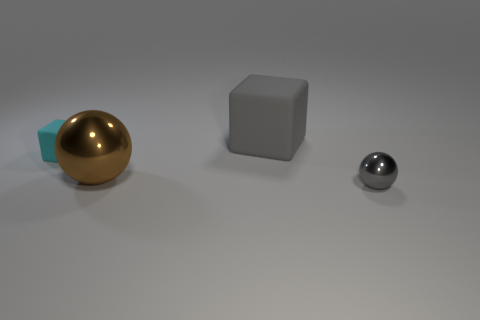Is there a object of the same color as the tiny rubber block?
Your answer should be very brief. No. There is a tiny gray thing that is made of the same material as the big brown ball; what shape is it?
Ensure brevity in your answer.  Sphere. Is the color of the tiny metal ball the same as the big cube?
Give a very brief answer. Yes. What is the material of the gray object that is the same shape as the big brown thing?
Provide a succinct answer. Metal. What number of other things are there of the same color as the tiny rubber block?
Give a very brief answer. 0. There is another thing that is the same size as the cyan object; what is it made of?
Offer a very short reply. Metal. What number of things are cubes behind the cyan rubber cube or big green spheres?
Ensure brevity in your answer.  1. Is there a big green rubber sphere?
Provide a short and direct response. No. There is a object that is behind the tiny cyan rubber object; what is its material?
Make the answer very short. Rubber. What is the material of the other thing that is the same color as the small shiny thing?
Ensure brevity in your answer.  Rubber. 